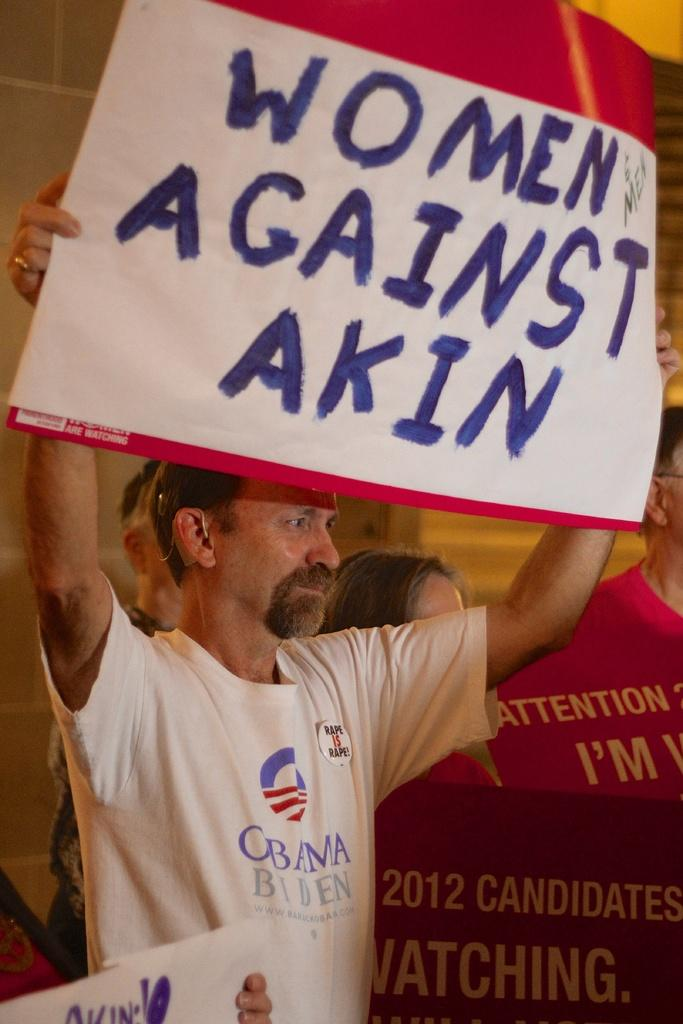<image>
Summarize the visual content of the image. A man holding up a sign for Women against Akin wearing an Obama Biden shirt. 